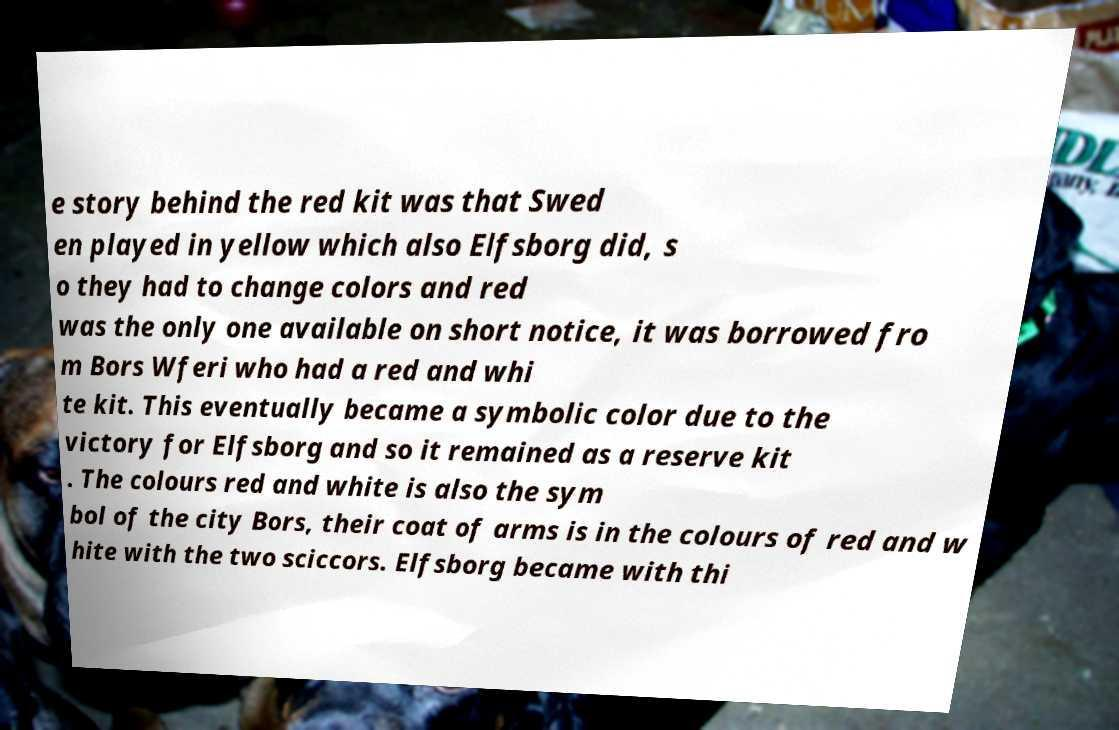I need the written content from this picture converted into text. Can you do that? e story behind the red kit was that Swed en played in yellow which also Elfsborg did, s o they had to change colors and red was the only one available on short notice, it was borrowed fro m Bors Wferi who had a red and whi te kit. This eventually became a symbolic color due to the victory for Elfsborg and so it remained as a reserve kit . The colours red and white is also the sym bol of the city Bors, their coat of arms is in the colours of red and w hite with the two sciccors. Elfsborg became with thi 